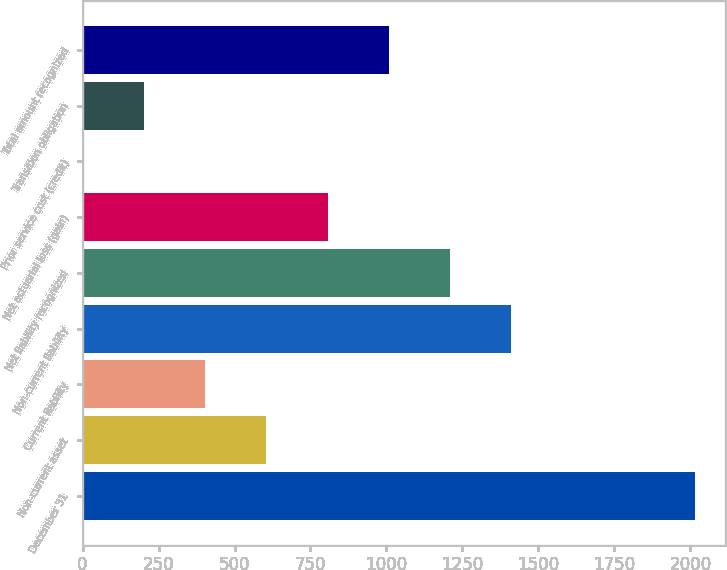Convert chart to OTSL. <chart><loc_0><loc_0><loc_500><loc_500><bar_chart><fcel>December 31<fcel>Non-current asset<fcel>Current liability<fcel>Non-current liability<fcel>Net liability recognized<fcel>Net actuarial loss (gain)<fcel>Prior service cost (credit)<fcel>Transition obligation<fcel>Total amount recognized<nl><fcel>2014<fcel>604.97<fcel>403.68<fcel>1410.13<fcel>1208.84<fcel>806.26<fcel>1.1<fcel>202.39<fcel>1007.55<nl></chart> 